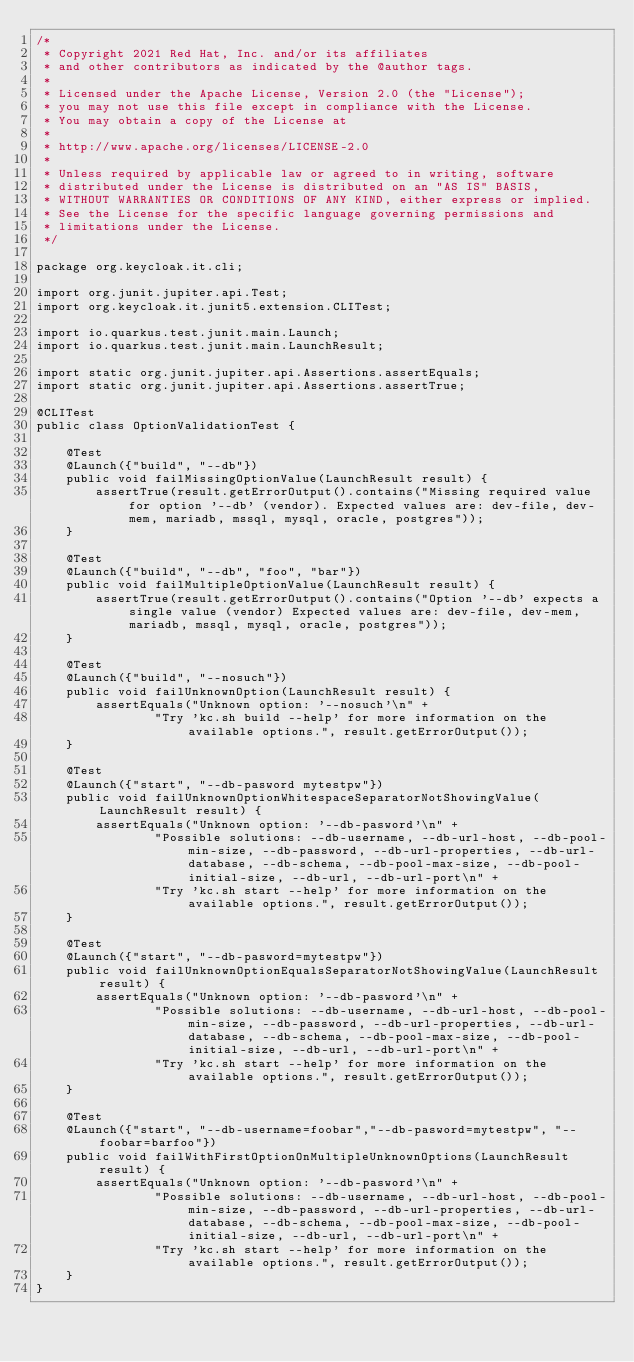<code> <loc_0><loc_0><loc_500><loc_500><_Java_>/*
 * Copyright 2021 Red Hat, Inc. and/or its affiliates
 * and other contributors as indicated by the @author tags.
 *
 * Licensed under the Apache License, Version 2.0 (the "License");
 * you may not use this file except in compliance with the License.
 * You may obtain a copy of the License at
 *
 * http://www.apache.org/licenses/LICENSE-2.0
 *
 * Unless required by applicable law or agreed to in writing, software
 * distributed under the License is distributed on an "AS IS" BASIS,
 * WITHOUT WARRANTIES OR CONDITIONS OF ANY KIND, either express or implied.
 * See the License for the specific language governing permissions and
 * limitations under the License.
 */

package org.keycloak.it.cli;

import org.junit.jupiter.api.Test;
import org.keycloak.it.junit5.extension.CLITest;

import io.quarkus.test.junit.main.Launch;
import io.quarkus.test.junit.main.LaunchResult;

import static org.junit.jupiter.api.Assertions.assertEquals;
import static org.junit.jupiter.api.Assertions.assertTrue;

@CLITest
public class OptionValidationTest {

    @Test
    @Launch({"build", "--db"})
    public void failMissingOptionValue(LaunchResult result) {
        assertTrue(result.getErrorOutput().contains("Missing required value for option '--db' (vendor). Expected values are: dev-file, dev-mem, mariadb, mssql, mysql, oracle, postgres"));
    }

    @Test
    @Launch({"build", "--db", "foo", "bar"})
    public void failMultipleOptionValue(LaunchResult result) {
        assertTrue(result.getErrorOutput().contains("Option '--db' expects a single value (vendor) Expected values are: dev-file, dev-mem, mariadb, mssql, mysql, oracle, postgres"));
    }

    @Test
    @Launch({"build", "--nosuch"})
    public void failUnknownOption(LaunchResult result) {
        assertEquals("Unknown option: '--nosuch'\n" +
                "Try 'kc.sh build --help' for more information on the available options.", result.getErrorOutput());
    }

    @Test
    @Launch({"start", "--db-pasword mytestpw"})
    public void failUnknownOptionWhitespaceSeparatorNotShowingValue(LaunchResult result) {
        assertEquals("Unknown option: '--db-pasword'\n" +
                "Possible solutions: --db-username, --db-url-host, --db-pool-min-size, --db-password, --db-url-properties, --db-url-database, --db-schema, --db-pool-max-size, --db-pool-initial-size, --db-url, --db-url-port\n" +
                "Try 'kc.sh start --help' for more information on the available options.", result.getErrorOutput());
    }

    @Test
    @Launch({"start", "--db-pasword=mytestpw"})
    public void failUnknownOptionEqualsSeparatorNotShowingValue(LaunchResult result) {
        assertEquals("Unknown option: '--db-pasword'\n" +
                "Possible solutions: --db-username, --db-url-host, --db-pool-min-size, --db-password, --db-url-properties, --db-url-database, --db-schema, --db-pool-max-size, --db-pool-initial-size, --db-url, --db-url-port\n" +
                "Try 'kc.sh start --help' for more information on the available options.", result.getErrorOutput());
    }

    @Test
    @Launch({"start", "--db-username=foobar","--db-pasword=mytestpw", "--foobar=barfoo"})
    public void failWithFirstOptionOnMultipleUnknownOptions(LaunchResult result) {
        assertEquals("Unknown option: '--db-pasword'\n" +
                "Possible solutions: --db-username, --db-url-host, --db-pool-min-size, --db-password, --db-url-properties, --db-url-database, --db-schema, --db-pool-max-size, --db-pool-initial-size, --db-url, --db-url-port\n" +
                "Try 'kc.sh start --help' for more information on the available options.", result.getErrorOutput());
    }
}
</code> 